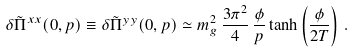<formula> <loc_0><loc_0><loc_500><loc_500>\delta \tilde { \Pi } ^ { x x } ( 0 , { p } ) \equiv \delta \tilde { \Pi } ^ { y y } ( 0 , { p } ) \simeq m _ { g } ^ { 2 } \, \frac { 3 \pi ^ { 2 } } { 4 } \, \frac { \phi } { p } \tanh \left ( \frac { \phi } { 2 T } \right ) \, .</formula> 